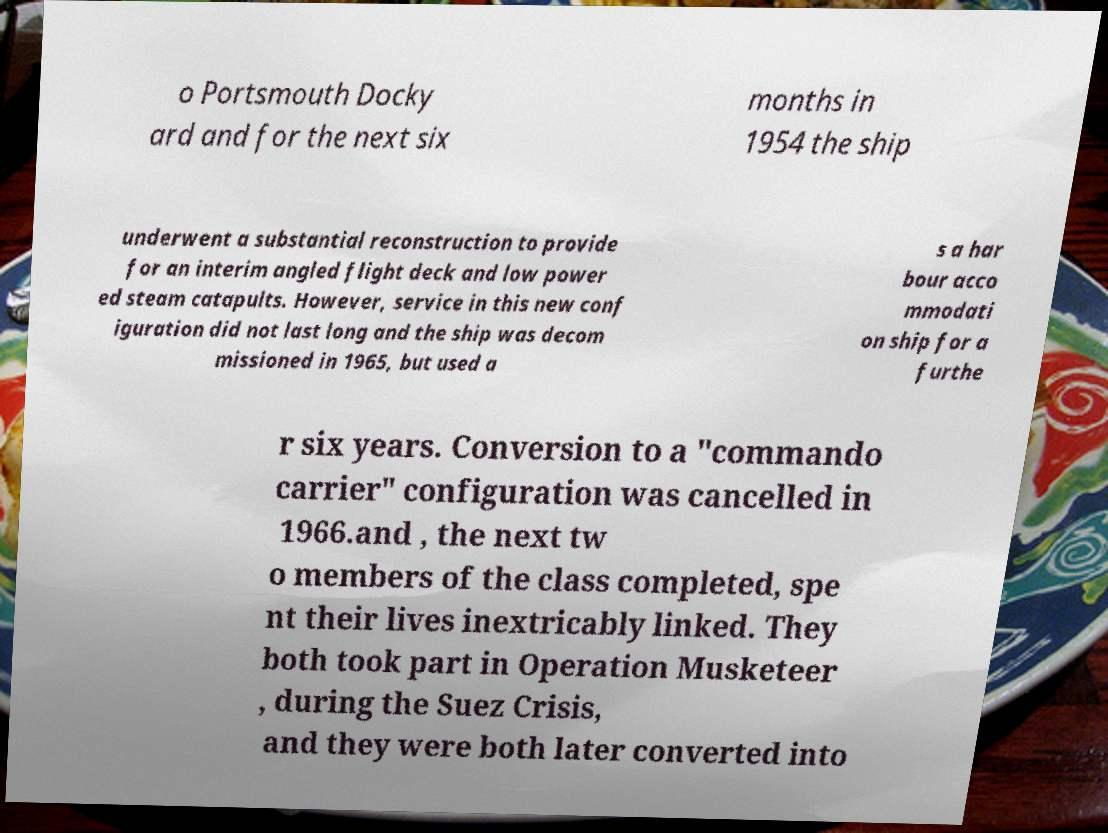There's text embedded in this image that I need extracted. Can you transcribe it verbatim? o Portsmouth Docky ard and for the next six months in 1954 the ship underwent a substantial reconstruction to provide for an interim angled flight deck and low power ed steam catapults. However, service in this new conf iguration did not last long and the ship was decom missioned in 1965, but used a s a har bour acco mmodati on ship for a furthe r six years. Conversion to a "commando carrier" configuration was cancelled in 1966.and , the next tw o members of the class completed, spe nt their lives inextricably linked. They both took part in Operation Musketeer , during the Suez Crisis, and they were both later converted into 